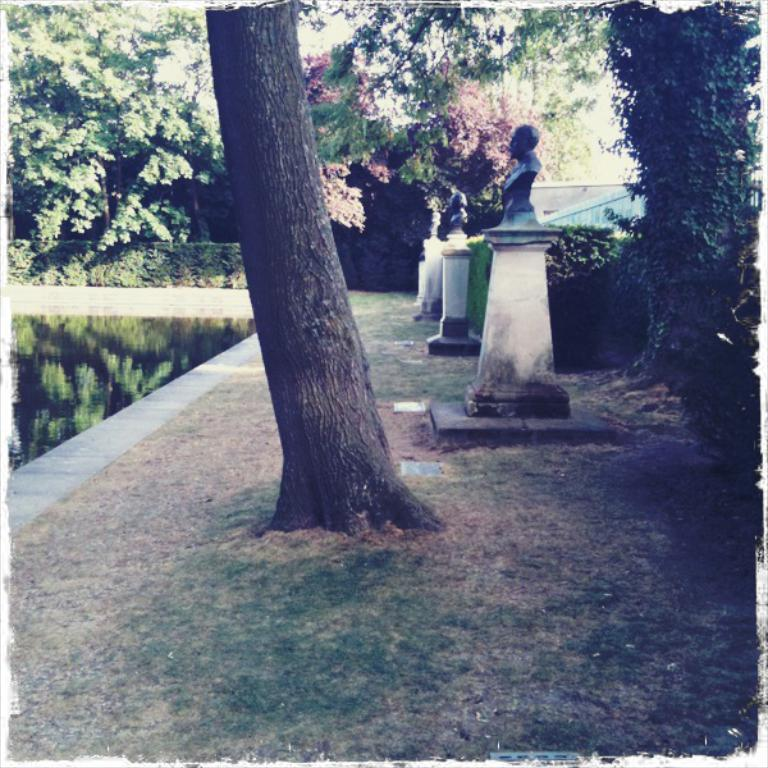What is the main subject of the image? There is a sculpture in the image. What type of natural environment is depicted in the image? There is grass, a tree trunk, and a tree present in the image, suggesting a natural setting. What is the water feature in the image? There is water visible in the image, and the reflection of trees is visible on the water. How many cows are grazing in the grass in the image? There are no cows present in the image; it features a sculpture, grass, a tree trunk, water, and the reflection of trees. 